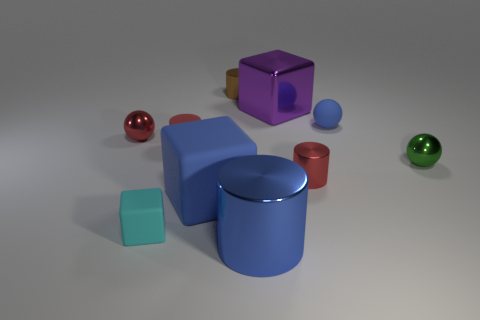How many shiny things are the same color as the tiny matte cylinder?
Your answer should be compact. 2. There is a large cylinder that is the same color as the tiny matte sphere; what is it made of?
Your answer should be very brief. Metal. What is the large block that is behind the metallic cylinder on the right side of the purple object made of?
Your answer should be very brief. Metal. Is there a blue object that has the same material as the blue cube?
Your answer should be compact. Yes. There is a brown cylinder that is the same size as the green ball; what material is it?
Ensure brevity in your answer.  Metal. There is a block behind the small metallic ball that is in front of the tiny red metal object that is left of the big purple metal cube; what size is it?
Provide a short and direct response. Large. Is there a metal object that is to the right of the red cylinder right of the big blue rubber block?
Ensure brevity in your answer.  Yes. There is a large rubber object; does it have the same shape as the metal thing to the right of the blue ball?
Your answer should be compact. No. There is a tiny metal cylinder that is in front of the large purple thing; what is its color?
Make the answer very short. Red. There is a blue thing on the right side of the red thing that is right of the purple shiny block; what size is it?
Your answer should be very brief. Small. 